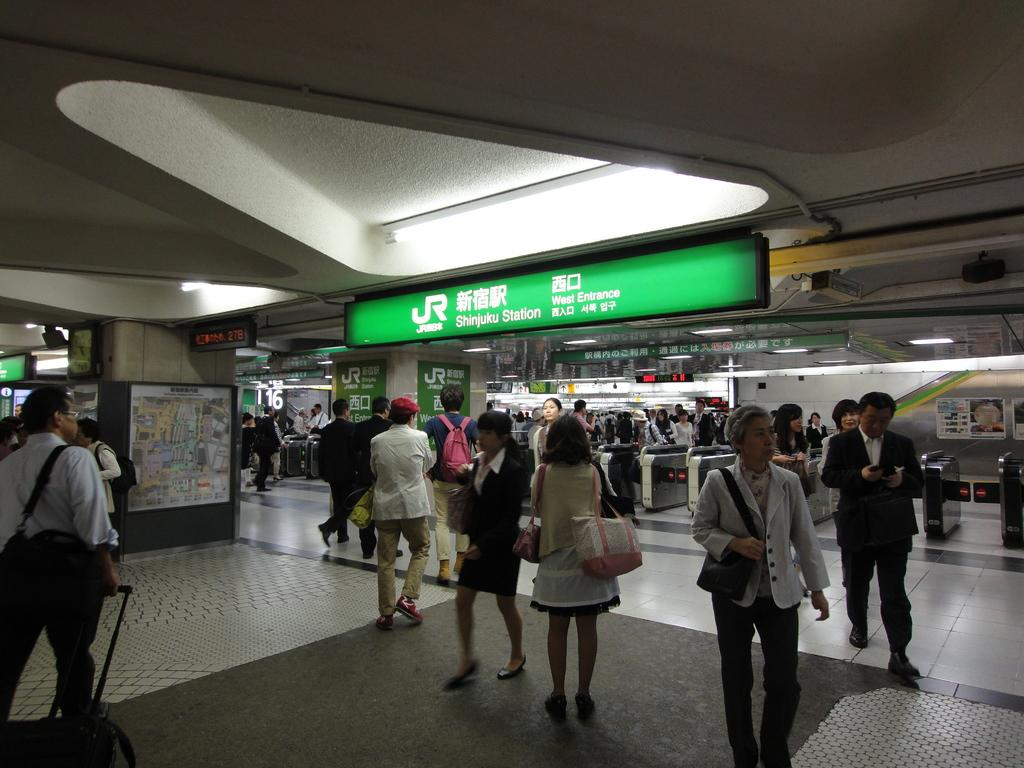How many people can be seen in the image? There are many people in the image. What are the people doing in the image? The people are standing and walking on the floor. Where might this image have been taken? The image appears to be taken in a mall. What can be seen in the background of the image? There are stores visible in the background. What type of lighting is present in the image? There are lights over the ceiling in the image. What type of flowers can be seen in the garden in the image? There is no garden present in the image; it appears to be taken in a mall. What time of day is it in the image? The provided facts do not mention the time of day, so it cannot be determined from the image. 